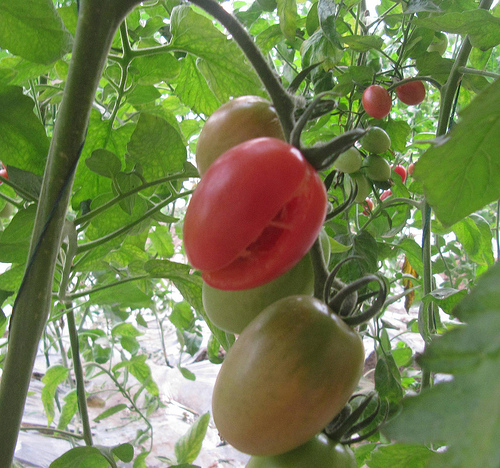<image>
Is there a tomato on the tomato? Yes. Looking at the image, I can see the tomato is positioned on top of the tomato, with the tomato providing support. 